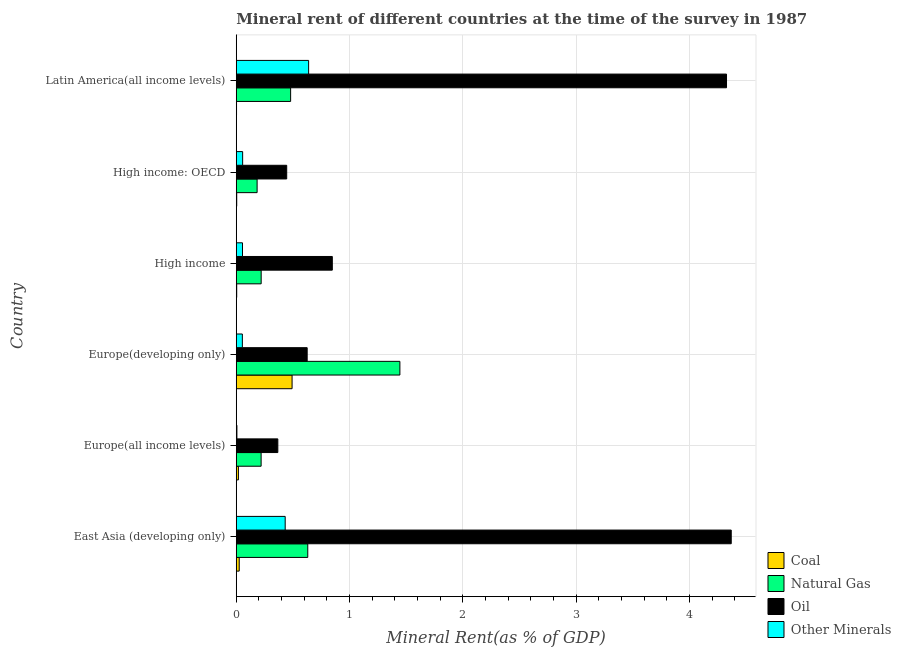How many groups of bars are there?
Offer a very short reply. 6. How many bars are there on the 1st tick from the top?
Provide a succinct answer. 4. What is the label of the 6th group of bars from the top?
Offer a terse response. East Asia (developing only). In how many cases, is the number of bars for a given country not equal to the number of legend labels?
Ensure brevity in your answer.  0. What is the  rent of other minerals in East Asia (developing only)?
Provide a short and direct response. 0.43. Across all countries, what is the maximum natural gas rent?
Provide a succinct answer. 1.44. Across all countries, what is the minimum oil rent?
Your response must be concise. 0.37. In which country was the oil rent maximum?
Provide a succinct answer. East Asia (developing only). In which country was the oil rent minimum?
Offer a very short reply. Europe(all income levels). What is the total  rent of other minerals in the graph?
Ensure brevity in your answer.  1.24. What is the difference between the  rent of other minerals in High income and that in Latin America(all income levels)?
Provide a succinct answer. -0.58. What is the difference between the oil rent in High income and the coal rent in High income: OECD?
Make the answer very short. 0.84. What is the average natural gas rent per country?
Provide a succinct answer. 0.53. What is the difference between the oil rent and  rent of other minerals in Europe(developing only)?
Ensure brevity in your answer.  0.57. In how many countries, is the oil rent greater than 4 %?
Make the answer very short. 2. What is the ratio of the  rent of other minerals in East Asia (developing only) to that in Europe(developing only)?
Provide a succinct answer. 8.01. Is the  rent of other minerals in Europe(all income levels) less than that in Europe(developing only)?
Ensure brevity in your answer.  Yes. What is the difference between the highest and the second highest natural gas rent?
Give a very brief answer. 0.81. What is the difference between the highest and the lowest coal rent?
Keep it short and to the point. 0.49. Is the sum of the coal rent in High income: OECD and Latin America(all income levels) greater than the maximum oil rent across all countries?
Your answer should be very brief. No. What does the 1st bar from the top in High income represents?
Ensure brevity in your answer.  Other Minerals. What does the 1st bar from the bottom in Latin America(all income levels) represents?
Your answer should be compact. Coal. Is it the case that in every country, the sum of the coal rent and natural gas rent is greater than the oil rent?
Give a very brief answer. No. How many bars are there?
Keep it short and to the point. 24. Are all the bars in the graph horizontal?
Your response must be concise. Yes. How many countries are there in the graph?
Keep it short and to the point. 6. What is the difference between two consecutive major ticks on the X-axis?
Provide a short and direct response. 1. How many legend labels are there?
Provide a short and direct response. 4. What is the title of the graph?
Your answer should be compact. Mineral rent of different countries at the time of the survey in 1987. Does "Secondary general" appear as one of the legend labels in the graph?
Make the answer very short. No. What is the label or title of the X-axis?
Your response must be concise. Mineral Rent(as % of GDP). What is the label or title of the Y-axis?
Your answer should be very brief. Country. What is the Mineral Rent(as % of GDP) in Coal in East Asia (developing only)?
Your answer should be compact. 0.03. What is the Mineral Rent(as % of GDP) in Natural Gas in East Asia (developing only)?
Keep it short and to the point. 0.63. What is the Mineral Rent(as % of GDP) in Oil in East Asia (developing only)?
Make the answer very short. 4.37. What is the Mineral Rent(as % of GDP) of Other Minerals in East Asia (developing only)?
Your answer should be compact. 0.43. What is the Mineral Rent(as % of GDP) in Coal in Europe(all income levels)?
Your response must be concise. 0.02. What is the Mineral Rent(as % of GDP) of Natural Gas in Europe(all income levels)?
Your response must be concise. 0.22. What is the Mineral Rent(as % of GDP) in Oil in Europe(all income levels)?
Provide a short and direct response. 0.37. What is the Mineral Rent(as % of GDP) of Other Minerals in Europe(all income levels)?
Keep it short and to the point. 0.01. What is the Mineral Rent(as % of GDP) of Coal in Europe(developing only)?
Provide a succinct answer. 0.49. What is the Mineral Rent(as % of GDP) of Natural Gas in Europe(developing only)?
Your response must be concise. 1.44. What is the Mineral Rent(as % of GDP) in Oil in Europe(developing only)?
Ensure brevity in your answer.  0.63. What is the Mineral Rent(as % of GDP) of Other Minerals in Europe(developing only)?
Ensure brevity in your answer.  0.05. What is the Mineral Rent(as % of GDP) in Coal in High income?
Your answer should be very brief. 0. What is the Mineral Rent(as % of GDP) of Natural Gas in High income?
Your answer should be compact. 0.22. What is the Mineral Rent(as % of GDP) in Oil in High income?
Your answer should be compact. 0.85. What is the Mineral Rent(as % of GDP) of Other Minerals in High income?
Provide a succinct answer. 0.06. What is the Mineral Rent(as % of GDP) in Coal in High income: OECD?
Provide a short and direct response. 0. What is the Mineral Rent(as % of GDP) in Natural Gas in High income: OECD?
Ensure brevity in your answer.  0.18. What is the Mineral Rent(as % of GDP) in Oil in High income: OECD?
Offer a very short reply. 0.45. What is the Mineral Rent(as % of GDP) in Other Minerals in High income: OECD?
Provide a succinct answer. 0.06. What is the Mineral Rent(as % of GDP) of Coal in Latin America(all income levels)?
Your answer should be very brief. 0. What is the Mineral Rent(as % of GDP) of Natural Gas in Latin America(all income levels)?
Provide a succinct answer. 0.48. What is the Mineral Rent(as % of GDP) in Oil in Latin America(all income levels)?
Ensure brevity in your answer.  4.33. What is the Mineral Rent(as % of GDP) of Other Minerals in Latin America(all income levels)?
Your answer should be compact. 0.64. Across all countries, what is the maximum Mineral Rent(as % of GDP) of Coal?
Your answer should be compact. 0.49. Across all countries, what is the maximum Mineral Rent(as % of GDP) of Natural Gas?
Your answer should be compact. 1.44. Across all countries, what is the maximum Mineral Rent(as % of GDP) in Oil?
Offer a terse response. 4.37. Across all countries, what is the maximum Mineral Rent(as % of GDP) of Other Minerals?
Provide a short and direct response. 0.64. Across all countries, what is the minimum Mineral Rent(as % of GDP) of Coal?
Your answer should be compact. 0. Across all countries, what is the minimum Mineral Rent(as % of GDP) in Natural Gas?
Provide a succinct answer. 0.18. Across all countries, what is the minimum Mineral Rent(as % of GDP) of Oil?
Offer a terse response. 0.37. Across all countries, what is the minimum Mineral Rent(as % of GDP) in Other Minerals?
Your response must be concise. 0.01. What is the total Mineral Rent(as % of GDP) in Coal in the graph?
Provide a succinct answer. 0.55. What is the total Mineral Rent(as % of GDP) in Natural Gas in the graph?
Ensure brevity in your answer.  3.18. What is the total Mineral Rent(as % of GDP) in Oil in the graph?
Your answer should be compact. 10.98. What is the total Mineral Rent(as % of GDP) of Other Minerals in the graph?
Give a very brief answer. 1.24. What is the difference between the Mineral Rent(as % of GDP) in Coal in East Asia (developing only) and that in Europe(all income levels)?
Make the answer very short. 0.01. What is the difference between the Mineral Rent(as % of GDP) of Natural Gas in East Asia (developing only) and that in Europe(all income levels)?
Ensure brevity in your answer.  0.41. What is the difference between the Mineral Rent(as % of GDP) in Oil in East Asia (developing only) and that in Europe(all income levels)?
Your answer should be very brief. 4. What is the difference between the Mineral Rent(as % of GDP) of Other Minerals in East Asia (developing only) and that in Europe(all income levels)?
Ensure brevity in your answer.  0.43. What is the difference between the Mineral Rent(as % of GDP) of Coal in East Asia (developing only) and that in Europe(developing only)?
Offer a very short reply. -0.47. What is the difference between the Mineral Rent(as % of GDP) of Natural Gas in East Asia (developing only) and that in Europe(developing only)?
Offer a very short reply. -0.81. What is the difference between the Mineral Rent(as % of GDP) of Oil in East Asia (developing only) and that in Europe(developing only)?
Offer a terse response. 3.74. What is the difference between the Mineral Rent(as % of GDP) in Other Minerals in East Asia (developing only) and that in Europe(developing only)?
Offer a very short reply. 0.38. What is the difference between the Mineral Rent(as % of GDP) in Coal in East Asia (developing only) and that in High income?
Offer a terse response. 0.02. What is the difference between the Mineral Rent(as % of GDP) of Natural Gas in East Asia (developing only) and that in High income?
Give a very brief answer. 0.41. What is the difference between the Mineral Rent(as % of GDP) of Oil in East Asia (developing only) and that in High income?
Offer a terse response. 3.52. What is the difference between the Mineral Rent(as % of GDP) of Other Minerals in East Asia (developing only) and that in High income?
Your response must be concise. 0.38. What is the difference between the Mineral Rent(as % of GDP) of Coal in East Asia (developing only) and that in High income: OECD?
Ensure brevity in your answer.  0.02. What is the difference between the Mineral Rent(as % of GDP) of Natural Gas in East Asia (developing only) and that in High income: OECD?
Offer a terse response. 0.45. What is the difference between the Mineral Rent(as % of GDP) in Oil in East Asia (developing only) and that in High income: OECD?
Your answer should be very brief. 3.92. What is the difference between the Mineral Rent(as % of GDP) in Other Minerals in East Asia (developing only) and that in High income: OECD?
Give a very brief answer. 0.38. What is the difference between the Mineral Rent(as % of GDP) in Coal in East Asia (developing only) and that in Latin America(all income levels)?
Make the answer very short. 0.02. What is the difference between the Mineral Rent(as % of GDP) of Natural Gas in East Asia (developing only) and that in Latin America(all income levels)?
Keep it short and to the point. 0.15. What is the difference between the Mineral Rent(as % of GDP) of Oil in East Asia (developing only) and that in Latin America(all income levels)?
Provide a short and direct response. 0.04. What is the difference between the Mineral Rent(as % of GDP) of Other Minerals in East Asia (developing only) and that in Latin America(all income levels)?
Your response must be concise. -0.21. What is the difference between the Mineral Rent(as % of GDP) in Coal in Europe(all income levels) and that in Europe(developing only)?
Provide a succinct answer. -0.47. What is the difference between the Mineral Rent(as % of GDP) of Natural Gas in Europe(all income levels) and that in Europe(developing only)?
Keep it short and to the point. -1.22. What is the difference between the Mineral Rent(as % of GDP) of Oil in Europe(all income levels) and that in Europe(developing only)?
Make the answer very short. -0.26. What is the difference between the Mineral Rent(as % of GDP) of Other Minerals in Europe(all income levels) and that in Europe(developing only)?
Keep it short and to the point. -0.05. What is the difference between the Mineral Rent(as % of GDP) of Coal in Europe(all income levels) and that in High income?
Offer a very short reply. 0.02. What is the difference between the Mineral Rent(as % of GDP) of Natural Gas in Europe(all income levels) and that in High income?
Your answer should be very brief. -0. What is the difference between the Mineral Rent(as % of GDP) of Oil in Europe(all income levels) and that in High income?
Make the answer very short. -0.48. What is the difference between the Mineral Rent(as % of GDP) in Other Minerals in Europe(all income levels) and that in High income?
Offer a terse response. -0.05. What is the difference between the Mineral Rent(as % of GDP) of Coal in Europe(all income levels) and that in High income: OECD?
Offer a very short reply. 0.01. What is the difference between the Mineral Rent(as % of GDP) of Natural Gas in Europe(all income levels) and that in High income: OECD?
Make the answer very short. 0.04. What is the difference between the Mineral Rent(as % of GDP) of Oil in Europe(all income levels) and that in High income: OECD?
Your answer should be compact. -0.08. What is the difference between the Mineral Rent(as % of GDP) in Other Minerals in Europe(all income levels) and that in High income: OECD?
Your response must be concise. -0.05. What is the difference between the Mineral Rent(as % of GDP) of Coal in Europe(all income levels) and that in Latin America(all income levels)?
Give a very brief answer. 0.02. What is the difference between the Mineral Rent(as % of GDP) of Natural Gas in Europe(all income levels) and that in Latin America(all income levels)?
Make the answer very short. -0.26. What is the difference between the Mineral Rent(as % of GDP) in Oil in Europe(all income levels) and that in Latin America(all income levels)?
Ensure brevity in your answer.  -3.96. What is the difference between the Mineral Rent(as % of GDP) of Other Minerals in Europe(all income levels) and that in Latin America(all income levels)?
Make the answer very short. -0.63. What is the difference between the Mineral Rent(as % of GDP) in Coal in Europe(developing only) and that in High income?
Keep it short and to the point. 0.49. What is the difference between the Mineral Rent(as % of GDP) in Natural Gas in Europe(developing only) and that in High income?
Provide a short and direct response. 1.22. What is the difference between the Mineral Rent(as % of GDP) in Oil in Europe(developing only) and that in High income?
Give a very brief answer. -0.22. What is the difference between the Mineral Rent(as % of GDP) of Other Minerals in Europe(developing only) and that in High income?
Give a very brief answer. -0. What is the difference between the Mineral Rent(as % of GDP) in Coal in Europe(developing only) and that in High income: OECD?
Give a very brief answer. 0.49. What is the difference between the Mineral Rent(as % of GDP) of Natural Gas in Europe(developing only) and that in High income: OECD?
Give a very brief answer. 1.26. What is the difference between the Mineral Rent(as % of GDP) of Oil in Europe(developing only) and that in High income: OECD?
Your answer should be very brief. 0.18. What is the difference between the Mineral Rent(as % of GDP) of Other Minerals in Europe(developing only) and that in High income: OECD?
Provide a succinct answer. -0. What is the difference between the Mineral Rent(as % of GDP) in Coal in Europe(developing only) and that in Latin America(all income levels)?
Offer a very short reply. 0.49. What is the difference between the Mineral Rent(as % of GDP) in Natural Gas in Europe(developing only) and that in Latin America(all income levels)?
Offer a terse response. 0.96. What is the difference between the Mineral Rent(as % of GDP) in Oil in Europe(developing only) and that in Latin America(all income levels)?
Your response must be concise. -3.7. What is the difference between the Mineral Rent(as % of GDP) of Other Minerals in Europe(developing only) and that in Latin America(all income levels)?
Your answer should be compact. -0.58. What is the difference between the Mineral Rent(as % of GDP) of Coal in High income and that in High income: OECD?
Offer a terse response. -0. What is the difference between the Mineral Rent(as % of GDP) of Natural Gas in High income and that in High income: OECD?
Make the answer very short. 0.04. What is the difference between the Mineral Rent(as % of GDP) of Oil in High income and that in High income: OECD?
Your answer should be compact. 0.4. What is the difference between the Mineral Rent(as % of GDP) in Other Minerals in High income and that in High income: OECD?
Your answer should be very brief. -0. What is the difference between the Mineral Rent(as % of GDP) of Coal in High income and that in Latin America(all income levels)?
Offer a very short reply. 0. What is the difference between the Mineral Rent(as % of GDP) of Natural Gas in High income and that in Latin America(all income levels)?
Your answer should be compact. -0.26. What is the difference between the Mineral Rent(as % of GDP) of Oil in High income and that in Latin America(all income levels)?
Offer a very short reply. -3.48. What is the difference between the Mineral Rent(as % of GDP) of Other Minerals in High income and that in Latin America(all income levels)?
Your answer should be compact. -0.58. What is the difference between the Mineral Rent(as % of GDP) of Coal in High income: OECD and that in Latin America(all income levels)?
Your answer should be compact. 0. What is the difference between the Mineral Rent(as % of GDP) of Natural Gas in High income: OECD and that in Latin America(all income levels)?
Offer a terse response. -0.3. What is the difference between the Mineral Rent(as % of GDP) of Oil in High income: OECD and that in Latin America(all income levels)?
Provide a short and direct response. -3.88. What is the difference between the Mineral Rent(as % of GDP) in Other Minerals in High income: OECD and that in Latin America(all income levels)?
Make the answer very short. -0.58. What is the difference between the Mineral Rent(as % of GDP) of Coal in East Asia (developing only) and the Mineral Rent(as % of GDP) of Natural Gas in Europe(all income levels)?
Keep it short and to the point. -0.19. What is the difference between the Mineral Rent(as % of GDP) of Coal in East Asia (developing only) and the Mineral Rent(as % of GDP) of Oil in Europe(all income levels)?
Your answer should be very brief. -0.34. What is the difference between the Mineral Rent(as % of GDP) in Coal in East Asia (developing only) and the Mineral Rent(as % of GDP) in Other Minerals in Europe(all income levels)?
Provide a succinct answer. 0.02. What is the difference between the Mineral Rent(as % of GDP) of Natural Gas in East Asia (developing only) and the Mineral Rent(as % of GDP) of Oil in Europe(all income levels)?
Provide a short and direct response. 0.26. What is the difference between the Mineral Rent(as % of GDP) of Natural Gas in East Asia (developing only) and the Mineral Rent(as % of GDP) of Other Minerals in Europe(all income levels)?
Your response must be concise. 0.63. What is the difference between the Mineral Rent(as % of GDP) in Oil in East Asia (developing only) and the Mineral Rent(as % of GDP) in Other Minerals in Europe(all income levels)?
Provide a succinct answer. 4.36. What is the difference between the Mineral Rent(as % of GDP) of Coal in East Asia (developing only) and the Mineral Rent(as % of GDP) of Natural Gas in Europe(developing only)?
Offer a terse response. -1.42. What is the difference between the Mineral Rent(as % of GDP) of Coal in East Asia (developing only) and the Mineral Rent(as % of GDP) of Other Minerals in Europe(developing only)?
Ensure brevity in your answer.  -0.03. What is the difference between the Mineral Rent(as % of GDP) in Natural Gas in East Asia (developing only) and the Mineral Rent(as % of GDP) in Oil in Europe(developing only)?
Your answer should be compact. 0.01. What is the difference between the Mineral Rent(as % of GDP) of Natural Gas in East Asia (developing only) and the Mineral Rent(as % of GDP) of Other Minerals in Europe(developing only)?
Give a very brief answer. 0.58. What is the difference between the Mineral Rent(as % of GDP) of Oil in East Asia (developing only) and the Mineral Rent(as % of GDP) of Other Minerals in Europe(developing only)?
Provide a succinct answer. 4.32. What is the difference between the Mineral Rent(as % of GDP) in Coal in East Asia (developing only) and the Mineral Rent(as % of GDP) in Natural Gas in High income?
Your answer should be compact. -0.19. What is the difference between the Mineral Rent(as % of GDP) in Coal in East Asia (developing only) and the Mineral Rent(as % of GDP) in Oil in High income?
Offer a terse response. -0.82. What is the difference between the Mineral Rent(as % of GDP) of Coal in East Asia (developing only) and the Mineral Rent(as % of GDP) of Other Minerals in High income?
Ensure brevity in your answer.  -0.03. What is the difference between the Mineral Rent(as % of GDP) in Natural Gas in East Asia (developing only) and the Mineral Rent(as % of GDP) in Oil in High income?
Your response must be concise. -0.22. What is the difference between the Mineral Rent(as % of GDP) in Natural Gas in East Asia (developing only) and the Mineral Rent(as % of GDP) in Other Minerals in High income?
Give a very brief answer. 0.58. What is the difference between the Mineral Rent(as % of GDP) in Oil in East Asia (developing only) and the Mineral Rent(as % of GDP) in Other Minerals in High income?
Offer a very short reply. 4.31. What is the difference between the Mineral Rent(as % of GDP) in Coal in East Asia (developing only) and the Mineral Rent(as % of GDP) in Natural Gas in High income: OECD?
Your response must be concise. -0.16. What is the difference between the Mineral Rent(as % of GDP) of Coal in East Asia (developing only) and the Mineral Rent(as % of GDP) of Oil in High income: OECD?
Provide a short and direct response. -0.42. What is the difference between the Mineral Rent(as % of GDP) of Coal in East Asia (developing only) and the Mineral Rent(as % of GDP) of Other Minerals in High income: OECD?
Make the answer very short. -0.03. What is the difference between the Mineral Rent(as % of GDP) in Natural Gas in East Asia (developing only) and the Mineral Rent(as % of GDP) in Oil in High income: OECD?
Your response must be concise. 0.19. What is the difference between the Mineral Rent(as % of GDP) of Natural Gas in East Asia (developing only) and the Mineral Rent(as % of GDP) of Other Minerals in High income: OECD?
Offer a very short reply. 0.57. What is the difference between the Mineral Rent(as % of GDP) in Oil in East Asia (developing only) and the Mineral Rent(as % of GDP) in Other Minerals in High income: OECD?
Ensure brevity in your answer.  4.31. What is the difference between the Mineral Rent(as % of GDP) of Coal in East Asia (developing only) and the Mineral Rent(as % of GDP) of Natural Gas in Latin America(all income levels)?
Your answer should be compact. -0.45. What is the difference between the Mineral Rent(as % of GDP) of Coal in East Asia (developing only) and the Mineral Rent(as % of GDP) of Oil in Latin America(all income levels)?
Provide a short and direct response. -4.3. What is the difference between the Mineral Rent(as % of GDP) in Coal in East Asia (developing only) and the Mineral Rent(as % of GDP) in Other Minerals in Latin America(all income levels)?
Your answer should be compact. -0.61. What is the difference between the Mineral Rent(as % of GDP) of Natural Gas in East Asia (developing only) and the Mineral Rent(as % of GDP) of Oil in Latin America(all income levels)?
Offer a very short reply. -3.7. What is the difference between the Mineral Rent(as % of GDP) of Natural Gas in East Asia (developing only) and the Mineral Rent(as % of GDP) of Other Minerals in Latin America(all income levels)?
Provide a succinct answer. -0.01. What is the difference between the Mineral Rent(as % of GDP) of Oil in East Asia (developing only) and the Mineral Rent(as % of GDP) of Other Minerals in Latin America(all income levels)?
Keep it short and to the point. 3.73. What is the difference between the Mineral Rent(as % of GDP) in Coal in Europe(all income levels) and the Mineral Rent(as % of GDP) in Natural Gas in Europe(developing only)?
Your response must be concise. -1.43. What is the difference between the Mineral Rent(as % of GDP) in Coal in Europe(all income levels) and the Mineral Rent(as % of GDP) in Oil in Europe(developing only)?
Provide a short and direct response. -0.61. What is the difference between the Mineral Rent(as % of GDP) in Coal in Europe(all income levels) and the Mineral Rent(as % of GDP) in Other Minerals in Europe(developing only)?
Ensure brevity in your answer.  -0.03. What is the difference between the Mineral Rent(as % of GDP) in Natural Gas in Europe(all income levels) and the Mineral Rent(as % of GDP) in Oil in Europe(developing only)?
Your answer should be compact. -0.41. What is the difference between the Mineral Rent(as % of GDP) of Natural Gas in Europe(all income levels) and the Mineral Rent(as % of GDP) of Other Minerals in Europe(developing only)?
Keep it short and to the point. 0.17. What is the difference between the Mineral Rent(as % of GDP) of Oil in Europe(all income levels) and the Mineral Rent(as % of GDP) of Other Minerals in Europe(developing only)?
Provide a succinct answer. 0.31. What is the difference between the Mineral Rent(as % of GDP) in Coal in Europe(all income levels) and the Mineral Rent(as % of GDP) in Natural Gas in High income?
Your response must be concise. -0.2. What is the difference between the Mineral Rent(as % of GDP) of Coal in Europe(all income levels) and the Mineral Rent(as % of GDP) of Oil in High income?
Your answer should be very brief. -0.83. What is the difference between the Mineral Rent(as % of GDP) of Coal in Europe(all income levels) and the Mineral Rent(as % of GDP) of Other Minerals in High income?
Offer a terse response. -0.04. What is the difference between the Mineral Rent(as % of GDP) in Natural Gas in Europe(all income levels) and the Mineral Rent(as % of GDP) in Oil in High income?
Provide a succinct answer. -0.63. What is the difference between the Mineral Rent(as % of GDP) in Natural Gas in Europe(all income levels) and the Mineral Rent(as % of GDP) in Other Minerals in High income?
Give a very brief answer. 0.16. What is the difference between the Mineral Rent(as % of GDP) in Oil in Europe(all income levels) and the Mineral Rent(as % of GDP) in Other Minerals in High income?
Offer a terse response. 0.31. What is the difference between the Mineral Rent(as % of GDP) in Coal in Europe(all income levels) and the Mineral Rent(as % of GDP) in Natural Gas in High income: OECD?
Make the answer very short. -0.17. What is the difference between the Mineral Rent(as % of GDP) in Coal in Europe(all income levels) and the Mineral Rent(as % of GDP) in Oil in High income: OECD?
Offer a terse response. -0.43. What is the difference between the Mineral Rent(as % of GDP) in Coal in Europe(all income levels) and the Mineral Rent(as % of GDP) in Other Minerals in High income: OECD?
Your answer should be very brief. -0.04. What is the difference between the Mineral Rent(as % of GDP) of Natural Gas in Europe(all income levels) and the Mineral Rent(as % of GDP) of Oil in High income: OECD?
Ensure brevity in your answer.  -0.23. What is the difference between the Mineral Rent(as % of GDP) of Natural Gas in Europe(all income levels) and the Mineral Rent(as % of GDP) of Other Minerals in High income: OECD?
Give a very brief answer. 0.16. What is the difference between the Mineral Rent(as % of GDP) of Oil in Europe(all income levels) and the Mineral Rent(as % of GDP) of Other Minerals in High income: OECD?
Ensure brevity in your answer.  0.31. What is the difference between the Mineral Rent(as % of GDP) of Coal in Europe(all income levels) and the Mineral Rent(as % of GDP) of Natural Gas in Latin America(all income levels)?
Provide a succinct answer. -0.46. What is the difference between the Mineral Rent(as % of GDP) of Coal in Europe(all income levels) and the Mineral Rent(as % of GDP) of Oil in Latin America(all income levels)?
Your answer should be very brief. -4.31. What is the difference between the Mineral Rent(as % of GDP) in Coal in Europe(all income levels) and the Mineral Rent(as % of GDP) in Other Minerals in Latin America(all income levels)?
Make the answer very short. -0.62. What is the difference between the Mineral Rent(as % of GDP) in Natural Gas in Europe(all income levels) and the Mineral Rent(as % of GDP) in Oil in Latin America(all income levels)?
Make the answer very short. -4.11. What is the difference between the Mineral Rent(as % of GDP) in Natural Gas in Europe(all income levels) and the Mineral Rent(as % of GDP) in Other Minerals in Latin America(all income levels)?
Your answer should be compact. -0.42. What is the difference between the Mineral Rent(as % of GDP) in Oil in Europe(all income levels) and the Mineral Rent(as % of GDP) in Other Minerals in Latin America(all income levels)?
Your response must be concise. -0.27. What is the difference between the Mineral Rent(as % of GDP) of Coal in Europe(developing only) and the Mineral Rent(as % of GDP) of Natural Gas in High income?
Give a very brief answer. 0.27. What is the difference between the Mineral Rent(as % of GDP) of Coal in Europe(developing only) and the Mineral Rent(as % of GDP) of Oil in High income?
Offer a terse response. -0.36. What is the difference between the Mineral Rent(as % of GDP) of Coal in Europe(developing only) and the Mineral Rent(as % of GDP) of Other Minerals in High income?
Ensure brevity in your answer.  0.44. What is the difference between the Mineral Rent(as % of GDP) of Natural Gas in Europe(developing only) and the Mineral Rent(as % of GDP) of Oil in High income?
Keep it short and to the point. 0.6. What is the difference between the Mineral Rent(as % of GDP) of Natural Gas in Europe(developing only) and the Mineral Rent(as % of GDP) of Other Minerals in High income?
Your response must be concise. 1.39. What is the difference between the Mineral Rent(as % of GDP) in Oil in Europe(developing only) and the Mineral Rent(as % of GDP) in Other Minerals in High income?
Ensure brevity in your answer.  0.57. What is the difference between the Mineral Rent(as % of GDP) of Coal in Europe(developing only) and the Mineral Rent(as % of GDP) of Natural Gas in High income: OECD?
Give a very brief answer. 0.31. What is the difference between the Mineral Rent(as % of GDP) in Coal in Europe(developing only) and the Mineral Rent(as % of GDP) in Oil in High income: OECD?
Your answer should be compact. 0.05. What is the difference between the Mineral Rent(as % of GDP) of Coal in Europe(developing only) and the Mineral Rent(as % of GDP) of Other Minerals in High income: OECD?
Make the answer very short. 0.44. What is the difference between the Mineral Rent(as % of GDP) of Natural Gas in Europe(developing only) and the Mineral Rent(as % of GDP) of Oil in High income: OECD?
Make the answer very short. 1. What is the difference between the Mineral Rent(as % of GDP) in Natural Gas in Europe(developing only) and the Mineral Rent(as % of GDP) in Other Minerals in High income: OECD?
Offer a very short reply. 1.39. What is the difference between the Mineral Rent(as % of GDP) of Oil in Europe(developing only) and the Mineral Rent(as % of GDP) of Other Minerals in High income: OECD?
Keep it short and to the point. 0.57. What is the difference between the Mineral Rent(as % of GDP) of Coal in Europe(developing only) and the Mineral Rent(as % of GDP) of Natural Gas in Latin America(all income levels)?
Provide a succinct answer. 0.01. What is the difference between the Mineral Rent(as % of GDP) in Coal in Europe(developing only) and the Mineral Rent(as % of GDP) in Oil in Latin America(all income levels)?
Ensure brevity in your answer.  -3.83. What is the difference between the Mineral Rent(as % of GDP) in Coal in Europe(developing only) and the Mineral Rent(as % of GDP) in Other Minerals in Latin America(all income levels)?
Offer a very short reply. -0.15. What is the difference between the Mineral Rent(as % of GDP) of Natural Gas in Europe(developing only) and the Mineral Rent(as % of GDP) of Oil in Latin America(all income levels)?
Your response must be concise. -2.88. What is the difference between the Mineral Rent(as % of GDP) of Natural Gas in Europe(developing only) and the Mineral Rent(as % of GDP) of Other Minerals in Latin America(all income levels)?
Offer a very short reply. 0.81. What is the difference between the Mineral Rent(as % of GDP) in Oil in Europe(developing only) and the Mineral Rent(as % of GDP) in Other Minerals in Latin America(all income levels)?
Offer a very short reply. -0.01. What is the difference between the Mineral Rent(as % of GDP) in Coal in High income and the Mineral Rent(as % of GDP) in Natural Gas in High income: OECD?
Keep it short and to the point. -0.18. What is the difference between the Mineral Rent(as % of GDP) in Coal in High income and the Mineral Rent(as % of GDP) in Oil in High income: OECD?
Ensure brevity in your answer.  -0.44. What is the difference between the Mineral Rent(as % of GDP) in Coal in High income and the Mineral Rent(as % of GDP) in Other Minerals in High income: OECD?
Your answer should be compact. -0.05. What is the difference between the Mineral Rent(as % of GDP) in Natural Gas in High income and the Mineral Rent(as % of GDP) in Oil in High income: OECD?
Ensure brevity in your answer.  -0.23. What is the difference between the Mineral Rent(as % of GDP) in Natural Gas in High income and the Mineral Rent(as % of GDP) in Other Minerals in High income: OECD?
Ensure brevity in your answer.  0.16. What is the difference between the Mineral Rent(as % of GDP) of Oil in High income and the Mineral Rent(as % of GDP) of Other Minerals in High income: OECD?
Give a very brief answer. 0.79. What is the difference between the Mineral Rent(as % of GDP) of Coal in High income and the Mineral Rent(as % of GDP) of Natural Gas in Latin America(all income levels)?
Provide a succinct answer. -0.48. What is the difference between the Mineral Rent(as % of GDP) of Coal in High income and the Mineral Rent(as % of GDP) of Oil in Latin America(all income levels)?
Ensure brevity in your answer.  -4.32. What is the difference between the Mineral Rent(as % of GDP) of Coal in High income and the Mineral Rent(as % of GDP) of Other Minerals in Latin America(all income levels)?
Ensure brevity in your answer.  -0.63. What is the difference between the Mineral Rent(as % of GDP) in Natural Gas in High income and the Mineral Rent(as % of GDP) in Oil in Latin America(all income levels)?
Make the answer very short. -4.11. What is the difference between the Mineral Rent(as % of GDP) of Natural Gas in High income and the Mineral Rent(as % of GDP) of Other Minerals in Latin America(all income levels)?
Offer a terse response. -0.42. What is the difference between the Mineral Rent(as % of GDP) of Oil in High income and the Mineral Rent(as % of GDP) of Other Minerals in Latin America(all income levels)?
Offer a very short reply. 0.21. What is the difference between the Mineral Rent(as % of GDP) in Coal in High income: OECD and the Mineral Rent(as % of GDP) in Natural Gas in Latin America(all income levels)?
Make the answer very short. -0.48. What is the difference between the Mineral Rent(as % of GDP) of Coal in High income: OECD and the Mineral Rent(as % of GDP) of Oil in Latin America(all income levels)?
Your response must be concise. -4.32. What is the difference between the Mineral Rent(as % of GDP) in Coal in High income: OECD and the Mineral Rent(as % of GDP) in Other Minerals in Latin America(all income levels)?
Provide a short and direct response. -0.63. What is the difference between the Mineral Rent(as % of GDP) of Natural Gas in High income: OECD and the Mineral Rent(as % of GDP) of Oil in Latin America(all income levels)?
Ensure brevity in your answer.  -4.14. What is the difference between the Mineral Rent(as % of GDP) of Natural Gas in High income: OECD and the Mineral Rent(as % of GDP) of Other Minerals in Latin America(all income levels)?
Give a very brief answer. -0.45. What is the difference between the Mineral Rent(as % of GDP) in Oil in High income: OECD and the Mineral Rent(as % of GDP) in Other Minerals in Latin America(all income levels)?
Provide a short and direct response. -0.19. What is the average Mineral Rent(as % of GDP) in Coal per country?
Keep it short and to the point. 0.09. What is the average Mineral Rent(as % of GDP) of Natural Gas per country?
Your answer should be compact. 0.53. What is the average Mineral Rent(as % of GDP) of Oil per country?
Offer a very short reply. 1.83. What is the average Mineral Rent(as % of GDP) of Other Minerals per country?
Ensure brevity in your answer.  0.21. What is the difference between the Mineral Rent(as % of GDP) in Coal and Mineral Rent(as % of GDP) in Natural Gas in East Asia (developing only)?
Provide a succinct answer. -0.61. What is the difference between the Mineral Rent(as % of GDP) in Coal and Mineral Rent(as % of GDP) in Oil in East Asia (developing only)?
Keep it short and to the point. -4.34. What is the difference between the Mineral Rent(as % of GDP) in Coal and Mineral Rent(as % of GDP) in Other Minerals in East Asia (developing only)?
Give a very brief answer. -0.41. What is the difference between the Mineral Rent(as % of GDP) of Natural Gas and Mineral Rent(as % of GDP) of Oil in East Asia (developing only)?
Your answer should be very brief. -3.74. What is the difference between the Mineral Rent(as % of GDP) in Natural Gas and Mineral Rent(as % of GDP) in Other Minerals in East Asia (developing only)?
Provide a succinct answer. 0.2. What is the difference between the Mineral Rent(as % of GDP) in Oil and Mineral Rent(as % of GDP) in Other Minerals in East Asia (developing only)?
Keep it short and to the point. 3.94. What is the difference between the Mineral Rent(as % of GDP) in Coal and Mineral Rent(as % of GDP) in Natural Gas in Europe(all income levels)?
Your answer should be very brief. -0.2. What is the difference between the Mineral Rent(as % of GDP) of Coal and Mineral Rent(as % of GDP) of Oil in Europe(all income levels)?
Your response must be concise. -0.35. What is the difference between the Mineral Rent(as % of GDP) in Coal and Mineral Rent(as % of GDP) in Other Minerals in Europe(all income levels)?
Your response must be concise. 0.01. What is the difference between the Mineral Rent(as % of GDP) in Natural Gas and Mineral Rent(as % of GDP) in Oil in Europe(all income levels)?
Give a very brief answer. -0.15. What is the difference between the Mineral Rent(as % of GDP) of Natural Gas and Mineral Rent(as % of GDP) of Other Minerals in Europe(all income levels)?
Give a very brief answer. 0.21. What is the difference between the Mineral Rent(as % of GDP) of Oil and Mineral Rent(as % of GDP) of Other Minerals in Europe(all income levels)?
Ensure brevity in your answer.  0.36. What is the difference between the Mineral Rent(as % of GDP) in Coal and Mineral Rent(as % of GDP) in Natural Gas in Europe(developing only)?
Provide a succinct answer. -0.95. What is the difference between the Mineral Rent(as % of GDP) of Coal and Mineral Rent(as % of GDP) of Oil in Europe(developing only)?
Offer a terse response. -0.13. What is the difference between the Mineral Rent(as % of GDP) of Coal and Mineral Rent(as % of GDP) of Other Minerals in Europe(developing only)?
Your answer should be compact. 0.44. What is the difference between the Mineral Rent(as % of GDP) of Natural Gas and Mineral Rent(as % of GDP) of Oil in Europe(developing only)?
Your answer should be compact. 0.82. What is the difference between the Mineral Rent(as % of GDP) in Natural Gas and Mineral Rent(as % of GDP) in Other Minerals in Europe(developing only)?
Offer a terse response. 1.39. What is the difference between the Mineral Rent(as % of GDP) in Oil and Mineral Rent(as % of GDP) in Other Minerals in Europe(developing only)?
Offer a very short reply. 0.57. What is the difference between the Mineral Rent(as % of GDP) of Coal and Mineral Rent(as % of GDP) of Natural Gas in High income?
Your answer should be very brief. -0.22. What is the difference between the Mineral Rent(as % of GDP) in Coal and Mineral Rent(as % of GDP) in Oil in High income?
Your response must be concise. -0.84. What is the difference between the Mineral Rent(as % of GDP) in Coal and Mineral Rent(as % of GDP) in Other Minerals in High income?
Ensure brevity in your answer.  -0.05. What is the difference between the Mineral Rent(as % of GDP) in Natural Gas and Mineral Rent(as % of GDP) in Oil in High income?
Offer a very short reply. -0.63. What is the difference between the Mineral Rent(as % of GDP) of Natural Gas and Mineral Rent(as % of GDP) of Other Minerals in High income?
Give a very brief answer. 0.16. What is the difference between the Mineral Rent(as % of GDP) in Oil and Mineral Rent(as % of GDP) in Other Minerals in High income?
Ensure brevity in your answer.  0.79. What is the difference between the Mineral Rent(as % of GDP) of Coal and Mineral Rent(as % of GDP) of Natural Gas in High income: OECD?
Provide a short and direct response. -0.18. What is the difference between the Mineral Rent(as % of GDP) in Coal and Mineral Rent(as % of GDP) in Oil in High income: OECD?
Offer a terse response. -0.44. What is the difference between the Mineral Rent(as % of GDP) in Coal and Mineral Rent(as % of GDP) in Other Minerals in High income: OECD?
Your answer should be very brief. -0.05. What is the difference between the Mineral Rent(as % of GDP) in Natural Gas and Mineral Rent(as % of GDP) in Oil in High income: OECD?
Offer a very short reply. -0.26. What is the difference between the Mineral Rent(as % of GDP) of Natural Gas and Mineral Rent(as % of GDP) of Other Minerals in High income: OECD?
Provide a short and direct response. 0.13. What is the difference between the Mineral Rent(as % of GDP) of Oil and Mineral Rent(as % of GDP) of Other Minerals in High income: OECD?
Give a very brief answer. 0.39. What is the difference between the Mineral Rent(as % of GDP) in Coal and Mineral Rent(as % of GDP) in Natural Gas in Latin America(all income levels)?
Ensure brevity in your answer.  -0.48. What is the difference between the Mineral Rent(as % of GDP) in Coal and Mineral Rent(as % of GDP) in Oil in Latin America(all income levels)?
Ensure brevity in your answer.  -4.33. What is the difference between the Mineral Rent(as % of GDP) of Coal and Mineral Rent(as % of GDP) of Other Minerals in Latin America(all income levels)?
Your answer should be very brief. -0.64. What is the difference between the Mineral Rent(as % of GDP) in Natural Gas and Mineral Rent(as % of GDP) in Oil in Latin America(all income levels)?
Provide a short and direct response. -3.85. What is the difference between the Mineral Rent(as % of GDP) of Natural Gas and Mineral Rent(as % of GDP) of Other Minerals in Latin America(all income levels)?
Offer a terse response. -0.16. What is the difference between the Mineral Rent(as % of GDP) of Oil and Mineral Rent(as % of GDP) of Other Minerals in Latin America(all income levels)?
Ensure brevity in your answer.  3.69. What is the ratio of the Mineral Rent(as % of GDP) in Coal in East Asia (developing only) to that in Europe(all income levels)?
Provide a succinct answer. 1.37. What is the ratio of the Mineral Rent(as % of GDP) of Natural Gas in East Asia (developing only) to that in Europe(all income levels)?
Your response must be concise. 2.88. What is the ratio of the Mineral Rent(as % of GDP) in Oil in East Asia (developing only) to that in Europe(all income levels)?
Make the answer very short. 11.9. What is the ratio of the Mineral Rent(as % of GDP) in Other Minerals in East Asia (developing only) to that in Europe(all income levels)?
Ensure brevity in your answer.  74.18. What is the ratio of the Mineral Rent(as % of GDP) in Coal in East Asia (developing only) to that in Europe(developing only)?
Offer a terse response. 0.05. What is the ratio of the Mineral Rent(as % of GDP) of Natural Gas in East Asia (developing only) to that in Europe(developing only)?
Offer a terse response. 0.44. What is the ratio of the Mineral Rent(as % of GDP) in Oil in East Asia (developing only) to that in Europe(developing only)?
Ensure brevity in your answer.  6.98. What is the ratio of the Mineral Rent(as % of GDP) of Other Minerals in East Asia (developing only) to that in Europe(developing only)?
Offer a terse response. 8.01. What is the ratio of the Mineral Rent(as % of GDP) in Coal in East Asia (developing only) to that in High income?
Keep it short and to the point. 6.68. What is the ratio of the Mineral Rent(as % of GDP) in Natural Gas in East Asia (developing only) to that in High income?
Offer a very short reply. 2.87. What is the ratio of the Mineral Rent(as % of GDP) in Oil in East Asia (developing only) to that in High income?
Keep it short and to the point. 5.15. What is the ratio of the Mineral Rent(as % of GDP) of Other Minerals in East Asia (developing only) to that in High income?
Keep it short and to the point. 7.82. What is the ratio of the Mineral Rent(as % of GDP) in Coal in East Asia (developing only) to that in High income: OECD?
Make the answer very short. 6.42. What is the ratio of the Mineral Rent(as % of GDP) in Natural Gas in East Asia (developing only) to that in High income: OECD?
Ensure brevity in your answer.  3.43. What is the ratio of the Mineral Rent(as % of GDP) of Oil in East Asia (developing only) to that in High income: OECD?
Your answer should be compact. 9.81. What is the ratio of the Mineral Rent(as % of GDP) of Other Minerals in East Asia (developing only) to that in High income: OECD?
Your answer should be very brief. 7.67. What is the ratio of the Mineral Rent(as % of GDP) in Coal in East Asia (developing only) to that in Latin America(all income levels)?
Provide a succinct answer. 10.5. What is the ratio of the Mineral Rent(as % of GDP) in Natural Gas in East Asia (developing only) to that in Latin America(all income levels)?
Keep it short and to the point. 1.32. What is the ratio of the Mineral Rent(as % of GDP) in Oil in East Asia (developing only) to that in Latin America(all income levels)?
Provide a succinct answer. 1.01. What is the ratio of the Mineral Rent(as % of GDP) of Other Minerals in East Asia (developing only) to that in Latin America(all income levels)?
Keep it short and to the point. 0.68. What is the ratio of the Mineral Rent(as % of GDP) in Coal in Europe(all income levels) to that in Europe(developing only)?
Give a very brief answer. 0.04. What is the ratio of the Mineral Rent(as % of GDP) in Natural Gas in Europe(all income levels) to that in Europe(developing only)?
Give a very brief answer. 0.15. What is the ratio of the Mineral Rent(as % of GDP) in Oil in Europe(all income levels) to that in Europe(developing only)?
Your response must be concise. 0.59. What is the ratio of the Mineral Rent(as % of GDP) of Other Minerals in Europe(all income levels) to that in Europe(developing only)?
Offer a terse response. 0.11. What is the ratio of the Mineral Rent(as % of GDP) of Coal in Europe(all income levels) to that in High income?
Offer a very short reply. 4.89. What is the ratio of the Mineral Rent(as % of GDP) of Oil in Europe(all income levels) to that in High income?
Provide a succinct answer. 0.43. What is the ratio of the Mineral Rent(as % of GDP) in Other Minerals in Europe(all income levels) to that in High income?
Offer a terse response. 0.11. What is the ratio of the Mineral Rent(as % of GDP) in Coal in Europe(all income levels) to that in High income: OECD?
Ensure brevity in your answer.  4.7. What is the ratio of the Mineral Rent(as % of GDP) in Natural Gas in Europe(all income levels) to that in High income: OECD?
Provide a succinct answer. 1.19. What is the ratio of the Mineral Rent(as % of GDP) in Oil in Europe(all income levels) to that in High income: OECD?
Offer a terse response. 0.82. What is the ratio of the Mineral Rent(as % of GDP) of Other Minerals in Europe(all income levels) to that in High income: OECD?
Give a very brief answer. 0.1. What is the ratio of the Mineral Rent(as % of GDP) of Coal in Europe(all income levels) to that in Latin America(all income levels)?
Give a very brief answer. 7.69. What is the ratio of the Mineral Rent(as % of GDP) in Natural Gas in Europe(all income levels) to that in Latin America(all income levels)?
Give a very brief answer. 0.46. What is the ratio of the Mineral Rent(as % of GDP) of Oil in Europe(all income levels) to that in Latin America(all income levels)?
Keep it short and to the point. 0.08. What is the ratio of the Mineral Rent(as % of GDP) of Other Minerals in Europe(all income levels) to that in Latin America(all income levels)?
Your answer should be very brief. 0.01. What is the ratio of the Mineral Rent(as % of GDP) of Coal in Europe(developing only) to that in High income?
Keep it short and to the point. 126.14. What is the ratio of the Mineral Rent(as % of GDP) in Natural Gas in Europe(developing only) to that in High income?
Provide a succinct answer. 6.57. What is the ratio of the Mineral Rent(as % of GDP) of Oil in Europe(developing only) to that in High income?
Ensure brevity in your answer.  0.74. What is the ratio of the Mineral Rent(as % of GDP) of Other Minerals in Europe(developing only) to that in High income?
Offer a very short reply. 0.98. What is the ratio of the Mineral Rent(as % of GDP) of Coal in Europe(developing only) to that in High income: OECD?
Ensure brevity in your answer.  121.21. What is the ratio of the Mineral Rent(as % of GDP) of Natural Gas in Europe(developing only) to that in High income: OECD?
Provide a succinct answer. 7.84. What is the ratio of the Mineral Rent(as % of GDP) in Oil in Europe(developing only) to that in High income: OECD?
Your response must be concise. 1.41. What is the ratio of the Mineral Rent(as % of GDP) in Other Minerals in Europe(developing only) to that in High income: OECD?
Make the answer very short. 0.96. What is the ratio of the Mineral Rent(as % of GDP) of Coal in Europe(developing only) to that in Latin America(all income levels)?
Keep it short and to the point. 198.24. What is the ratio of the Mineral Rent(as % of GDP) in Natural Gas in Europe(developing only) to that in Latin America(all income levels)?
Keep it short and to the point. 3.01. What is the ratio of the Mineral Rent(as % of GDP) in Oil in Europe(developing only) to that in Latin America(all income levels)?
Offer a very short reply. 0.14. What is the ratio of the Mineral Rent(as % of GDP) of Other Minerals in Europe(developing only) to that in Latin America(all income levels)?
Offer a terse response. 0.08. What is the ratio of the Mineral Rent(as % of GDP) in Coal in High income to that in High income: OECD?
Provide a short and direct response. 0.96. What is the ratio of the Mineral Rent(as % of GDP) in Natural Gas in High income to that in High income: OECD?
Ensure brevity in your answer.  1.19. What is the ratio of the Mineral Rent(as % of GDP) of Oil in High income to that in High income: OECD?
Your answer should be compact. 1.9. What is the ratio of the Mineral Rent(as % of GDP) of Other Minerals in High income to that in High income: OECD?
Offer a very short reply. 0.98. What is the ratio of the Mineral Rent(as % of GDP) of Coal in High income to that in Latin America(all income levels)?
Offer a very short reply. 1.57. What is the ratio of the Mineral Rent(as % of GDP) of Natural Gas in High income to that in Latin America(all income levels)?
Provide a short and direct response. 0.46. What is the ratio of the Mineral Rent(as % of GDP) of Oil in High income to that in Latin America(all income levels)?
Keep it short and to the point. 0.2. What is the ratio of the Mineral Rent(as % of GDP) of Other Minerals in High income to that in Latin America(all income levels)?
Offer a very short reply. 0.09. What is the ratio of the Mineral Rent(as % of GDP) in Coal in High income: OECD to that in Latin America(all income levels)?
Make the answer very short. 1.64. What is the ratio of the Mineral Rent(as % of GDP) of Natural Gas in High income: OECD to that in Latin America(all income levels)?
Your answer should be very brief. 0.38. What is the ratio of the Mineral Rent(as % of GDP) in Oil in High income: OECD to that in Latin America(all income levels)?
Ensure brevity in your answer.  0.1. What is the ratio of the Mineral Rent(as % of GDP) in Other Minerals in High income: OECD to that in Latin America(all income levels)?
Your answer should be compact. 0.09. What is the difference between the highest and the second highest Mineral Rent(as % of GDP) of Coal?
Provide a succinct answer. 0.47. What is the difference between the highest and the second highest Mineral Rent(as % of GDP) of Natural Gas?
Offer a terse response. 0.81. What is the difference between the highest and the second highest Mineral Rent(as % of GDP) in Oil?
Make the answer very short. 0.04. What is the difference between the highest and the second highest Mineral Rent(as % of GDP) of Other Minerals?
Provide a succinct answer. 0.21. What is the difference between the highest and the lowest Mineral Rent(as % of GDP) of Coal?
Your answer should be very brief. 0.49. What is the difference between the highest and the lowest Mineral Rent(as % of GDP) of Natural Gas?
Your response must be concise. 1.26. What is the difference between the highest and the lowest Mineral Rent(as % of GDP) of Oil?
Offer a terse response. 4. What is the difference between the highest and the lowest Mineral Rent(as % of GDP) of Other Minerals?
Your response must be concise. 0.63. 